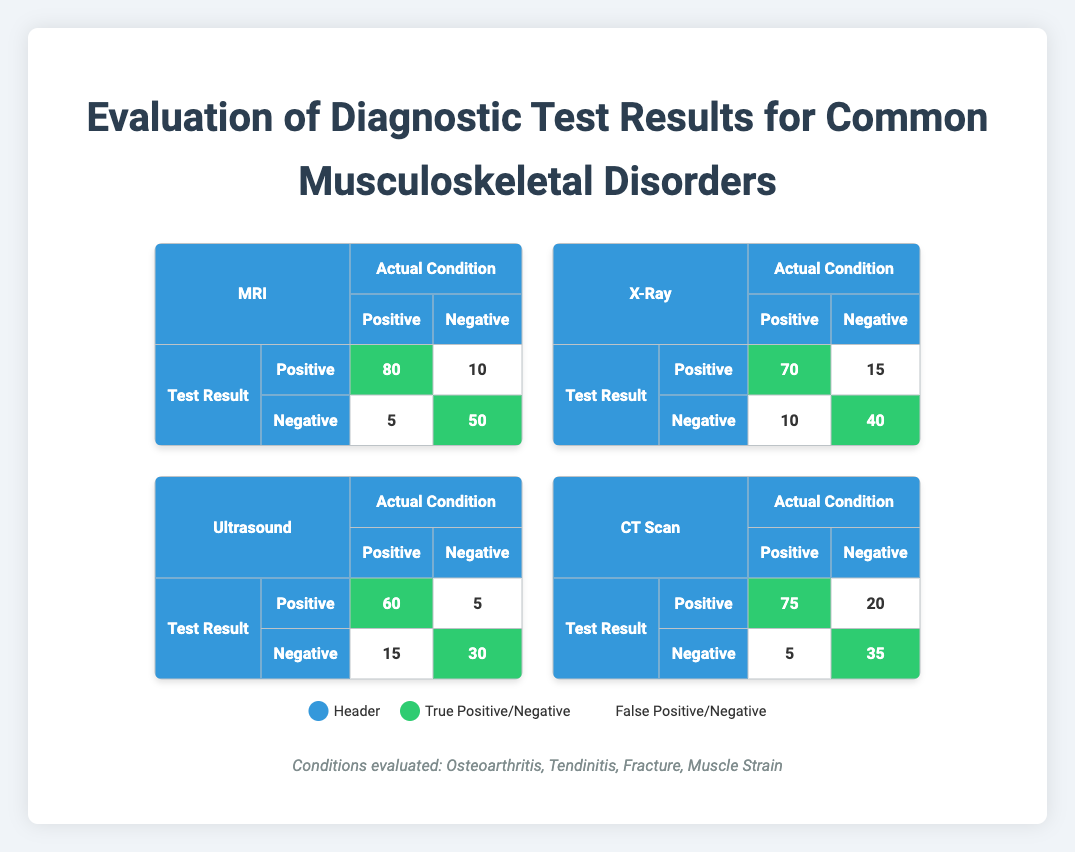What is the true positive rate for the MRI test? The true positive rate is calculated by taking the number of true positives (80) and dividing it by the total number of actual positives, which is the sum of true positives and false negatives (80 + 5 = 85). Therefore, the true positive rate for MRI is 80/85 = approximately 0.941 or 94.1%.
Answer: 94.1% How many total false positives does the X-Ray test have? The false positives for the X-Ray test are listed as 15. This number is taken directly from the table, which allows for quick reference.
Answer: 15 Which diagnostic test has the highest number of true negatives? The number of true negatives for MRI is 50, X-Ray is 40, Ultrasound is 30, and CT Scan is 35. Among these values, MRI has the highest at 50.
Answer: MRI What is the average number of true positives across all diagnostic tests? Adding the true positives: (80 + 70 + 60 + 75) = 285. Since there are four tests, the average is 285/4 = 71.25.
Answer: 71.25 Is the number of false negatives for Ultrasound greater than that for the CT Scan test? The false negatives for Ultrasound are 15, while for CT Scan they are 5. Since 15 is greater than 5, we conclude that this statement is true.
Answer: Yes What is the total number of positive test results (true positives plus false positives) for the CT Scan? For the CT Scan, true positives are 75 and false positives are 20. Summing these gives 75 + 20 = 95 positive test results.
Answer: 95 How many total conditions were evaluated in this study? The table lists four conditions: Osteoarthritis, Tendinitis, Fracture, and Muscle Strain. Counting these gives a total of four conditions evaluated.
Answer: 4 Which test has the lowest number of true positives, and what is that number? The true positives for each test are: MRI (80), X-Ray (70), Ultrasound (60), and CT Scan (75). Ultrasound has the lowest number of true positives at 60.
Answer: Ultrasound, 60 What is the difference between the highest and lowest true negative counts among the tests? The highest true negative count is from MRI at 50, and the lowest from Ultrasound at 30. The difference is 50 - 30 = 20.
Answer: 20 